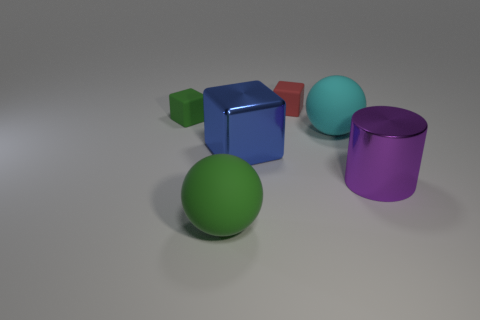Add 2 purple cylinders. How many objects exist? 8 Subtract all cylinders. How many objects are left? 5 Add 6 large balls. How many large balls exist? 8 Subtract 0 blue balls. How many objects are left? 6 Subtract all cyan balls. Subtract all big objects. How many objects are left? 1 Add 4 green matte spheres. How many green matte spheres are left? 5 